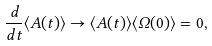Convert formula to latex. <formula><loc_0><loc_0><loc_500><loc_500>\frac { d } { d t } \langle A ( t ) \rangle \to \langle A ( t ) \rangle \langle \Omega ( 0 ) \rangle = 0 ,</formula> 